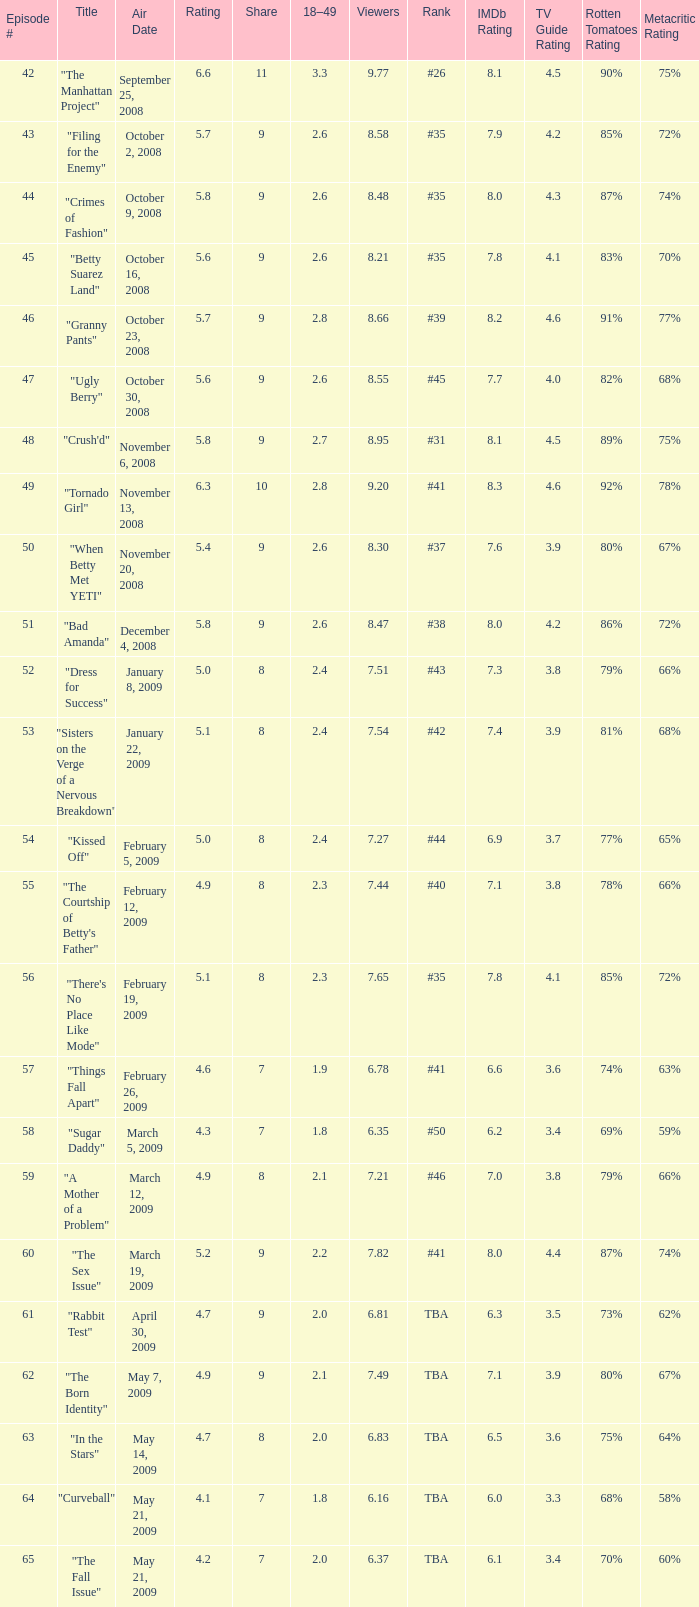What is the total number of Viewers when the rank is #40? 1.0. 